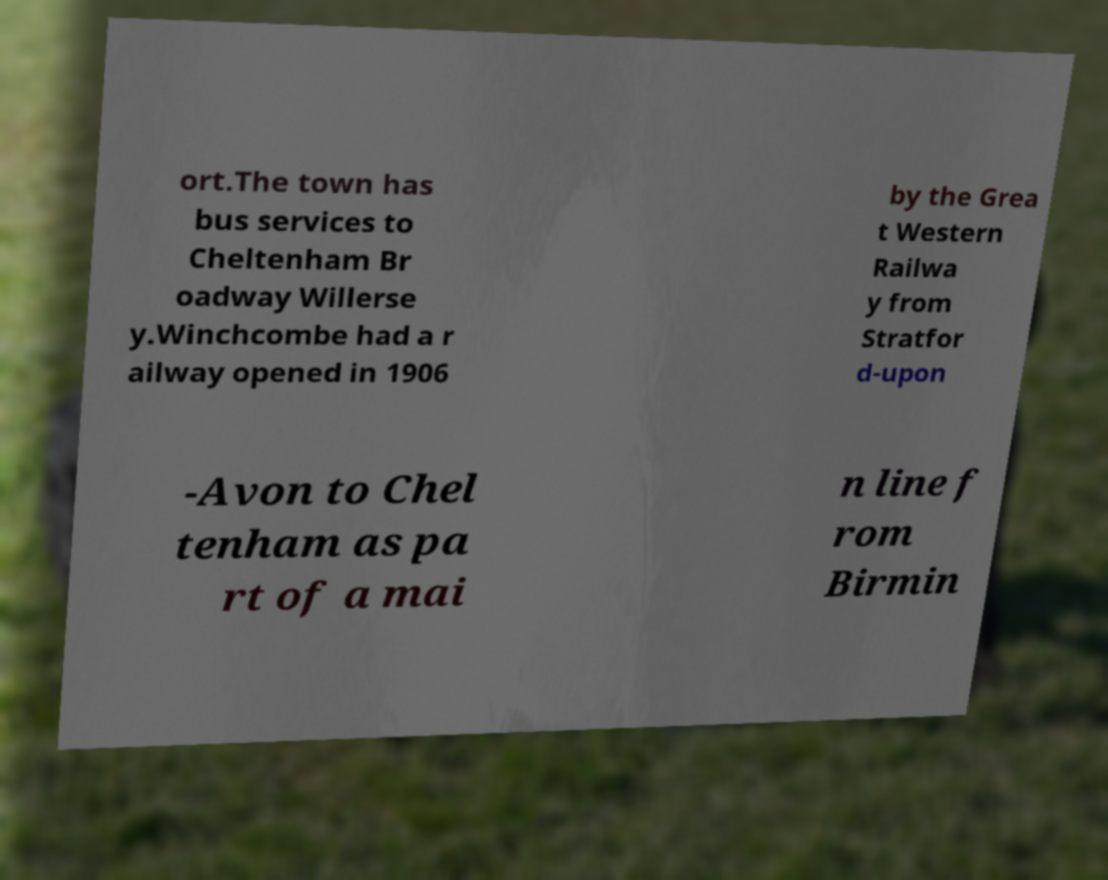Could you assist in decoding the text presented in this image and type it out clearly? ort.The town has bus services to Cheltenham Br oadway Willerse y.Winchcombe had a r ailway opened in 1906 by the Grea t Western Railwa y from Stratfor d-upon -Avon to Chel tenham as pa rt of a mai n line f rom Birmin 